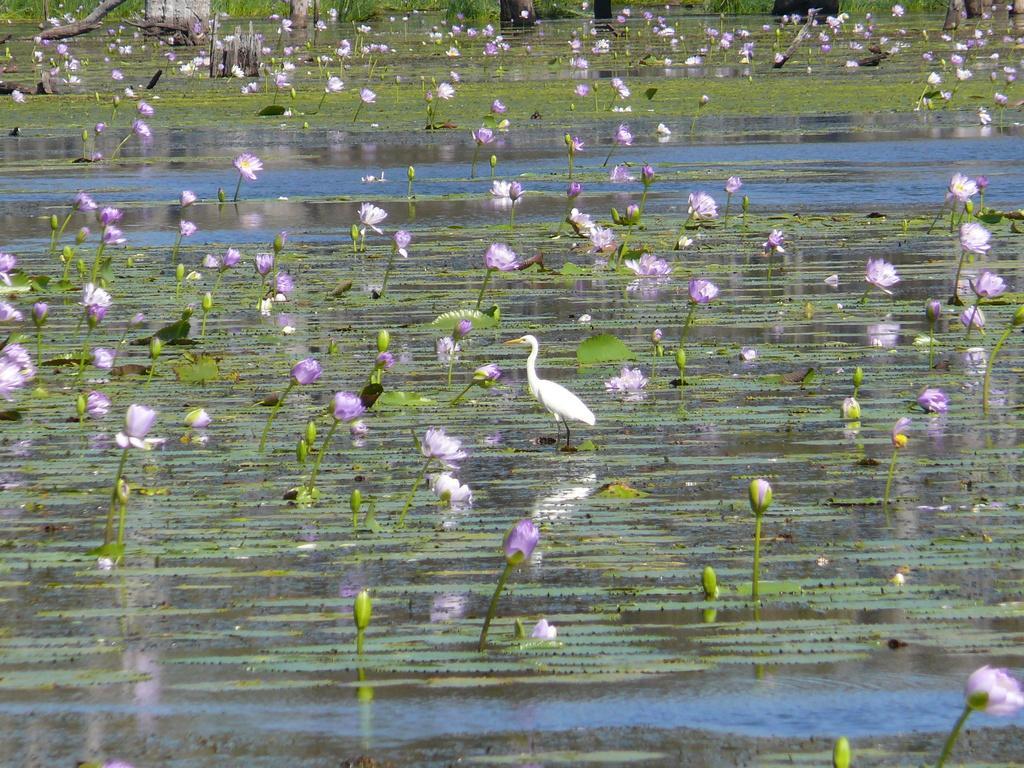In one or two sentences, can you explain what this image depicts? In the picture I can see the lotus flowers in the water and I can see the algae floating on the water. I can see a crane bird in the water and it is in the middle of the picture. 